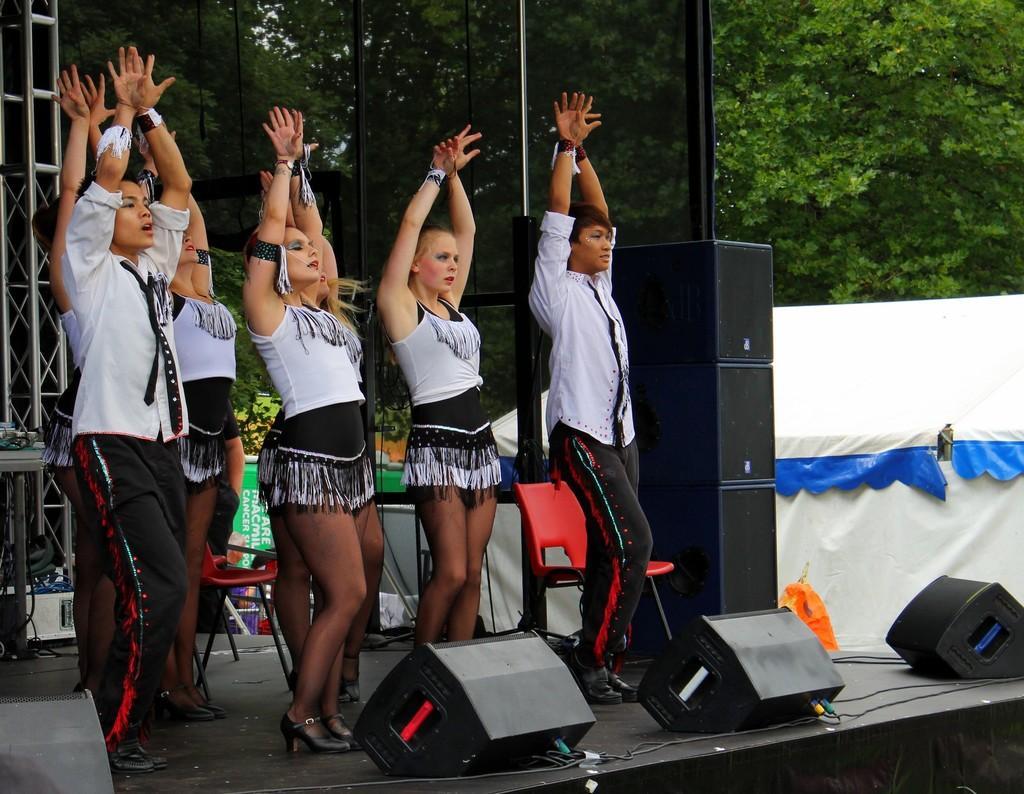Could you give a brief overview of what you see in this image? On the left side, there are women and men dancing on a stage, on which there are speakers, poles and chairs arranged. In the background, there is a tent, there are trees and other objects. 